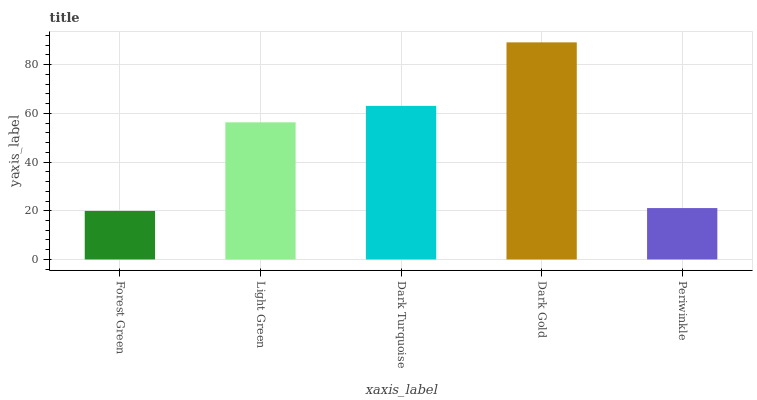Is Forest Green the minimum?
Answer yes or no. Yes. Is Dark Gold the maximum?
Answer yes or no. Yes. Is Light Green the minimum?
Answer yes or no. No. Is Light Green the maximum?
Answer yes or no. No. Is Light Green greater than Forest Green?
Answer yes or no. Yes. Is Forest Green less than Light Green?
Answer yes or no. Yes. Is Forest Green greater than Light Green?
Answer yes or no. No. Is Light Green less than Forest Green?
Answer yes or no. No. Is Light Green the high median?
Answer yes or no. Yes. Is Light Green the low median?
Answer yes or no. Yes. Is Dark Gold the high median?
Answer yes or no. No. Is Periwinkle the low median?
Answer yes or no. No. 